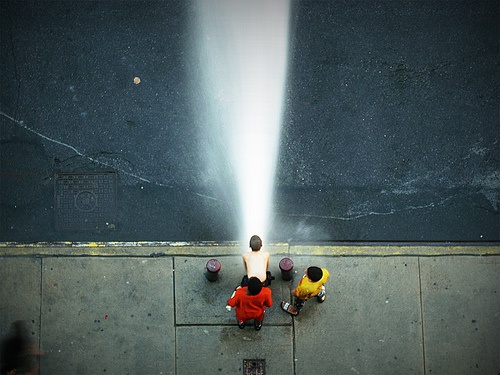Describe the objects in this image and their specific colors. I can see people in black, maroon, and red tones, people in black, gold, and olive tones, and people in black, ivory, gray, and tan tones in this image. 